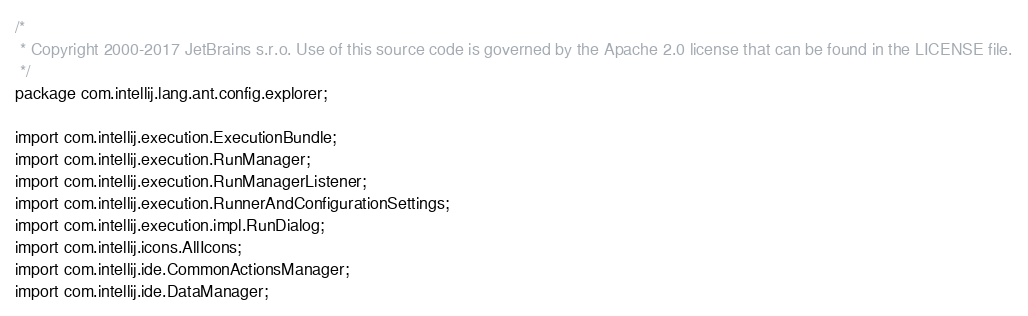Convert code to text. <code><loc_0><loc_0><loc_500><loc_500><_Java_>/*
 * Copyright 2000-2017 JetBrains s.r.o. Use of this source code is governed by the Apache 2.0 license that can be found in the LICENSE file.
 */
package com.intellij.lang.ant.config.explorer;

import com.intellij.execution.ExecutionBundle;
import com.intellij.execution.RunManager;
import com.intellij.execution.RunManagerListener;
import com.intellij.execution.RunnerAndConfigurationSettings;
import com.intellij.execution.impl.RunDialog;
import com.intellij.icons.AllIcons;
import com.intellij.ide.CommonActionsManager;
import com.intellij.ide.DataManager;</code> 